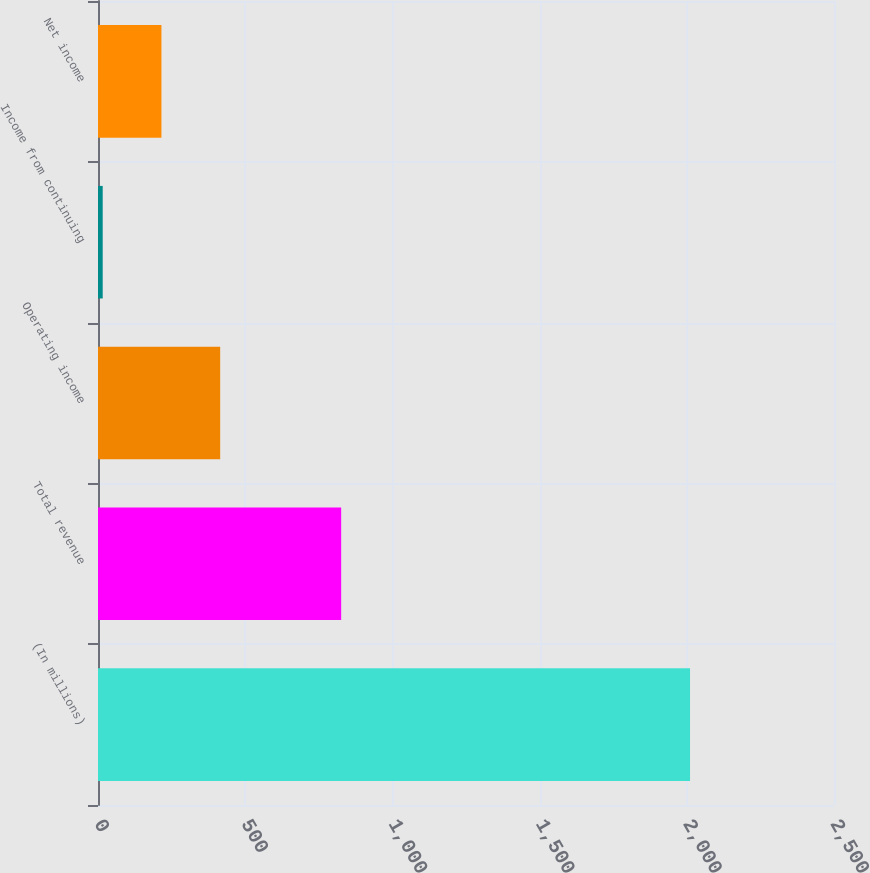Convert chart. <chart><loc_0><loc_0><loc_500><loc_500><bar_chart><fcel>(In millions)<fcel>Total revenue<fcel>Operating income<fcel>Income from continuing<fcel>Net income<nl><fcel>2011<fcel>826<fcel>415<fcel>16<fcel>215.5<nl></chart> 